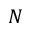<formula> <loc_0><loc_0><loc_500><loc_500>N</formula> 